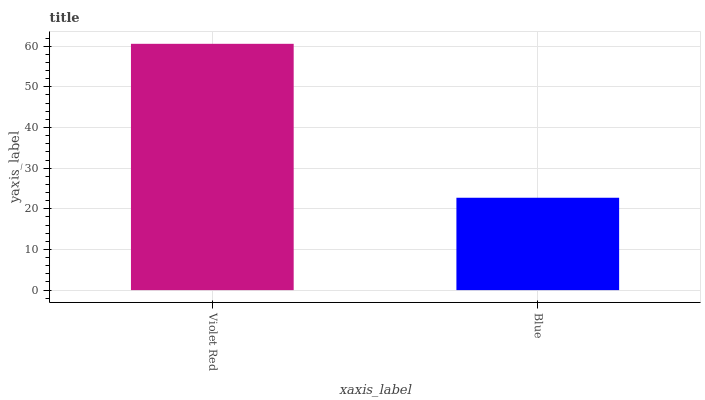Is Blue the minimum?
Answer yes or no. Yes. Is Violet Red the maximum?
Answer yes or no. Yes. Is Blue the maximum?
Answer yes or no. No. Is Violet Red greater than Blue?
Answer yes or no. Yes. Is Blue less than Violet Red?
Answer yes or no. Yes. Is Blue greater than Violet Red?
Answer yes or no. No. Is Violet Red less than Blue?
Answer yes or no. No. Is Violet Red the high median?
Answer yes or no. Yes. Is Blue the low median?
Answer yes or no. Yes. Is Blue the high median?
Answer yes or no. No. Is Violet Red the low median?
Answer yes or no. No. 